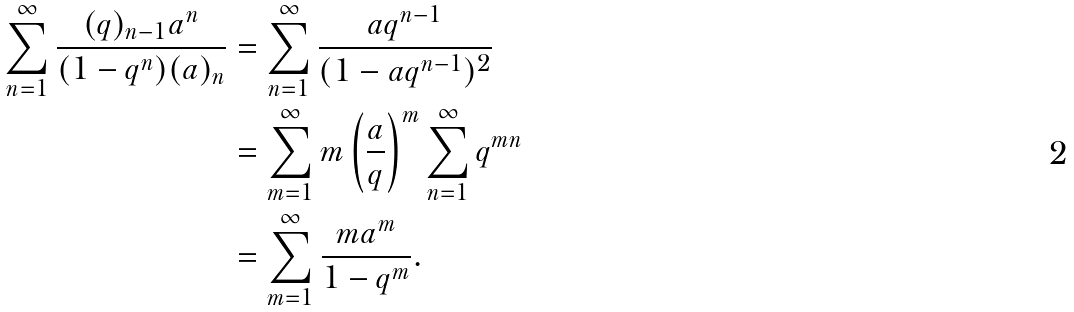<formula> <loc_0><loc_0><loc_500><loc_500>\sum _ { n = 1 } ^ { \infty } \frac { ( q ) _ { n - 1 } a ^ { n } } { ( 1 - q ^ { n } ) ( a ) _ { n } } & = \sum _ { n = 1 } ^ { \infty } \frac { a q ^ { n - 1 } } { ( 1 - a q ^ { n - 1 } ) ^ { 2 } } \\ & = \sum _ { m = 1 } ^ { \infty } m \left ( \frac { a } { q } \right ) ^ { m } \sum _ { n = 1 } ^ { \infty } q ^ { m n } \\ & = \sum _ { m = 1 } ^ { \infty } \frac { m a ^ { m } } { 1 - q ^ { m } } .</formula> 